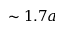Convert formula to latex. <formula><loc_0><loc_0><loc_500><loc_500>\sim 1 . 7 a</formula> 